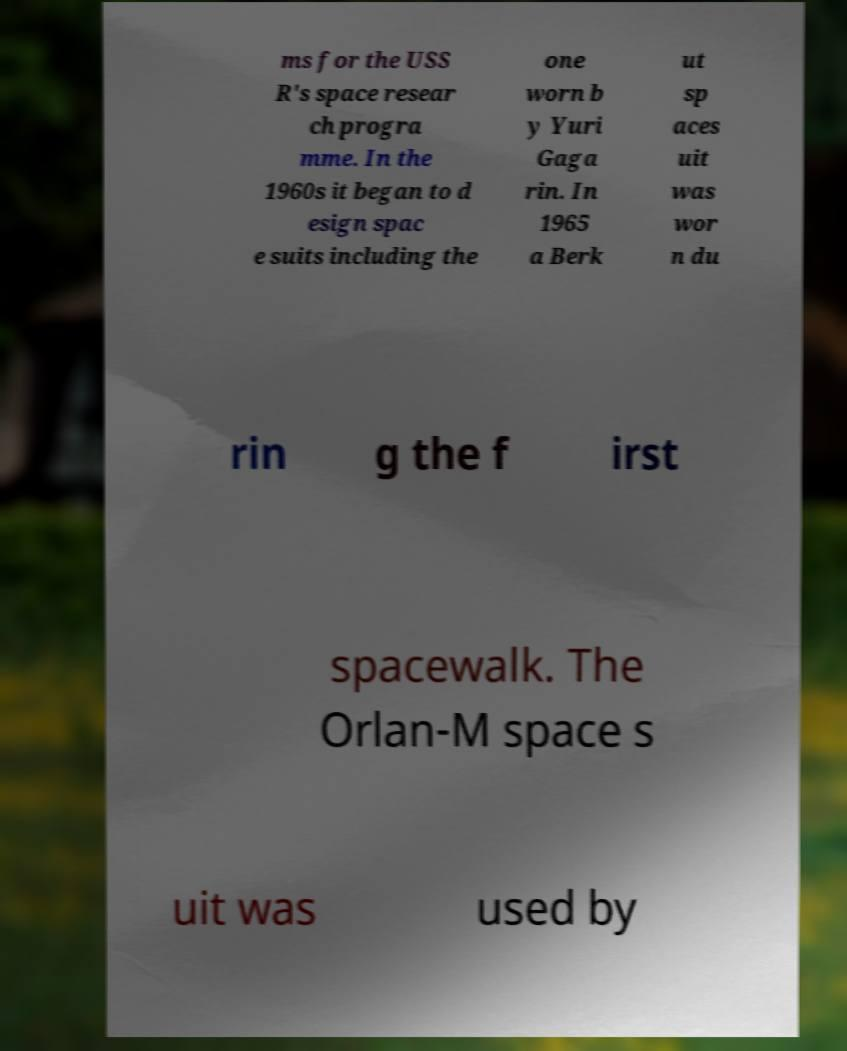Could you assist in decoding the text presented in this image and type it out clearly? ms for the USS R's space resear ch progra mme. In the 1960s it began to d esign spac e suits including the one worn b y Yuri Gaga rin. In 1965 a Berk ut sp aces uit was wor n du rin g the f irst spacewalk. The Orlan-M space s uit was used by 